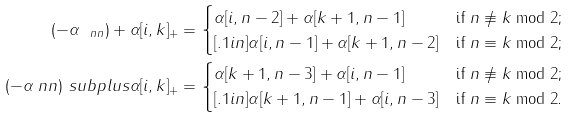Convert formula to latex. <formula><loc_0><loc_0><loc_500><loc_500>( - \alpha _ { \ n n } ) + \alpha [ i , k ] _ { + } & = \begin{cases} \alpha [ i , n - 2 ] + \alpha [ k + 1 , n - 1 ] & \text {if $n \not\equiv k \bmod2$;} \\ [ . 1 i n ] \alpha [ i , n - 1 ] + \alpha [ k + 1 , n - 2 ] & \text {if $n \equiv k \bmod2$;} \end{cases} \\ ( - \alpha _ { \ } n n ) \ s u b p l u s \alpha [ i , k ] _ { + } & = \begin{cases} \alpha [ k + 1 , n - 3 ] + \alpha [ i , n - 1 ] & \text {if $n \not\equiv k \bmod2$;} \\ [ . 1 i n ] \alpha [ k + 1 , n - 1 ] + \alpha [ i , n - 3 ] & \text {if $n \equiv k \bmod2$.} \end{cases}</formula> 